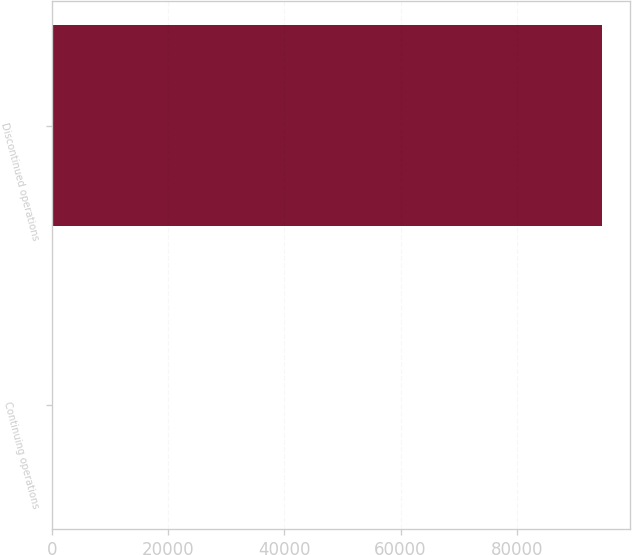Convert chart to OTSL. <chart><loc_0><loc_0><loc_500><loc_500><bar_chart><fcel>Continuing operations<fcel>Discontinued operations<nl><fcel>128<fcel>94776<nl></chart> 